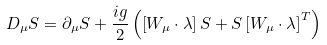<formula> <loc_0><loc_0><loc_500><loc_500>D _ { \mu } S = \partial _ { \mu } S + \frac { i g } { 2 } \left ( \left [ { W _ { \mu } \cdot \lambda } \right ] S + S \left [ { W _ { \mu } \cdot \lambda } \right ] ^ { T } \right )</formula> 